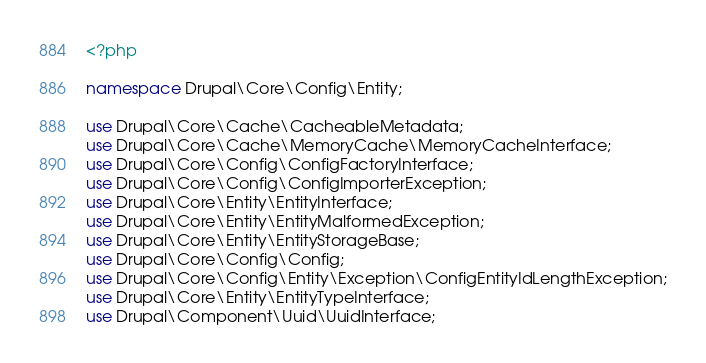<code> <loc_0><loc_0><loc_500><loc_500><_PHP_><?php

namespace Drupal\Core\Config\Entity;

use Drupal\Core\Cache\CacheableMetadata;
use Drupal\Core\Cache\MemoryCache\MemoryCacheInterface;
use Drupal\Core\Config\ConfigFactoryInterface;
use Drupal\Core\Config\ConfigImporterException;
use Drupal\Core\Entity\EntityInterface;
use Drupal\Core\Entity\EntityMalformedException;
use Drupal\Core\Entity\EntityStorageBase;
use Drupal\Core\Config\Config;
use Drupal\Core\Config\Entity\Exception\ConfigEntityIdLengthException;
use Drupal\Core\Entity\EntityTypeInterface;
use Drupal\Component\Uuid\UuidInterface;</code> 